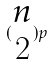<formula> <loc_0><loc_0><loc_500><loc_500>( \begin{matrix} n \\ 2 \end{matrix} ) p</formula> 